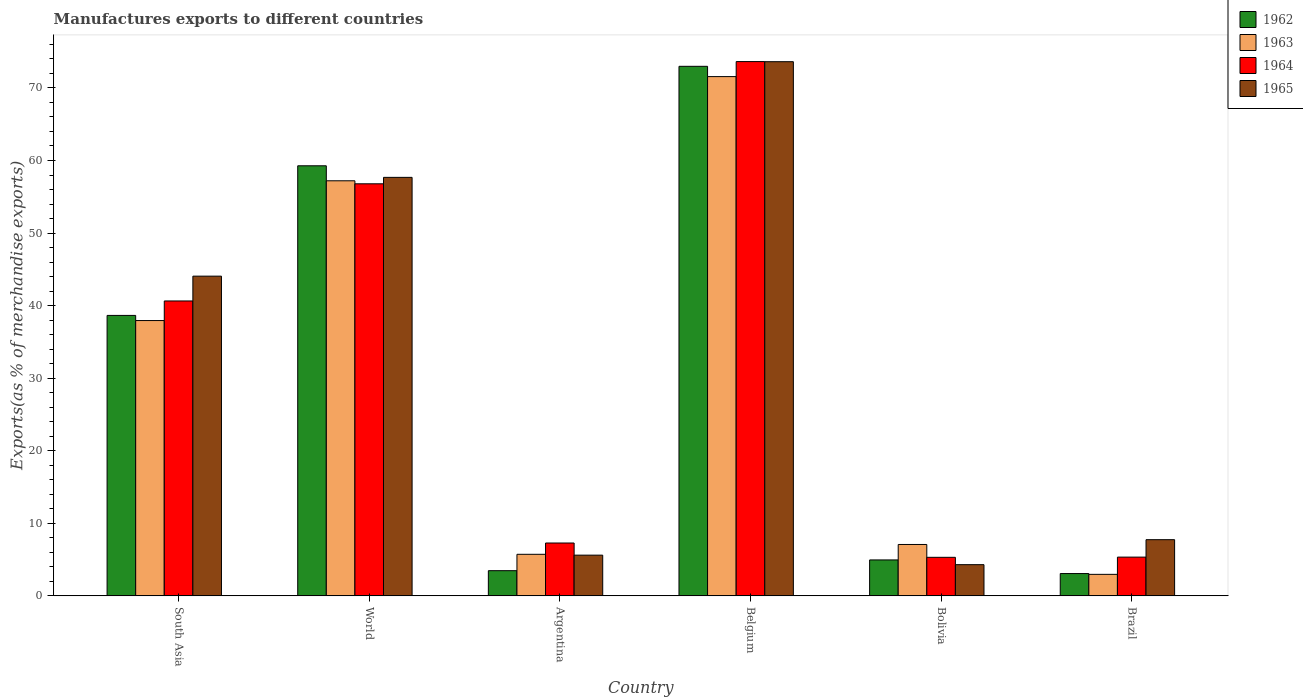How many different coloured bars are there?
Provide a succinct answer. 4. In how many cases, is the number of bars for a given country not equal to the number of legend labels?
Provide a succinct answer. 0. What is the percentage of exports to different countries in 1963 in Belgium?
Your answer should be compact. 71.56. Across all countries, what is the maximum percentage of exports to different countries in 1964?
Provide a short and direct response. 73.63. Across all countries, what is the minimum percentage of exports to different countries in 1963?
Ensure brevity in your answer.  2.96. In which country was the percentage of exports to different countries in 1962 minimum?
Give a very brief answer. Brazil. What is the total percentage of exports to different countries in 1962 in the graph?
Offer a very short reply. 182.39. What is the difference between the percentage of exports to different countries in 1965 in Argentina and that in South Asia?
Your answer should be compact. -38.45. What is the difference between the percentage of exports to different countries in 1965 in South Asia and the percentage of exports to different countries in 1962 in Argentina?
Provide a short and direct response. 40.59. What is the average percentage of exports to different countries in 1963 per country?
Ensure brevity in your answer.  30.41. What is the difference between the percentage of exports to different countries of/in 1963 and percentage of exports to different countries of/in 1962 in Brazil?
Your answer should be very brief. -0.11. In how many countries, is the percentage of exports to different countries in 1965 greater than 48 %?
Your answer should be very brief. 2. What is the ratio of the percentage of exports to different countries in 1964 in Argentina to that in Bolivia?
Offer a very short reply. 1.37. Is the difference between the percentage of exports to different countries in 1963 in South Asia and World greater than the difference between the percentage of exports to different countries in 1962 in South Asia and World?
Offer a terse response. Yes. What is the difference between the highest and the second highest percentage of exports to different countries in 1965?
Your answer should be very brief. 29.56. What is the difference between the highest and the lowest percentage of exports to different countries in 1964?
Make the answer very short. 68.32. In how many countries, is the percentage of exports to different countries in 1963 greater than the average percentage of exports to different countries in 1963 taken over all countries?
Provide a succinct answer. 3. What does the 3rd bar from the left in World represents?
Ensure brevity in your answer.  1964. What does the 2nd bar from the right in Argentina represents?
Give a very brief answer. 1964. Is it the case that in every country, the sum of the percentage of exports to different countries in 1962 and percentage of exports to different countries in 1964 is greater than the percentage of exports to different countries in 1965?
Your answer should be compact. Yes. How many bars are there?
Offer a very short reply. 24. What is the difference between two consecutive major ticks on the Y-axis?
Offer a terse response. 10. Does the graph contain any zero values?
Your response must be concise. No. Does the graph contain grids?
Keep it short and to the point. No. Where does the legend appear in the graph?
Offer a terse response. Top right. How are the legend labels stacked?
Offer a very short reply. Vertical. What is the title of the graph?
Make the answer very short. Manufactures exports to different countries. What is the label or title of the Y-axis?
Keep it short and to the point. Exports(as % of merchandise exports). What is the Exports(as % of merchandise exports) of 1962 in South Asia?
Your answer should be compact. 38.65. What is the Exports(as % of merchandise exports) in 1963 in South Asia?
Make the answer very short. 37.94. What is the Exports(as % of merchandise exports) of 1964 in South Asia?
Offer a terse response. 40.64. What is the Exports(as % of merchandise exports) in 1965 in South Asia?
Your answer should be very brief. 44.06. What is the Exports(as % of merchandise exports) of 1962 in World?
Your answer should be very brief. 59.27. What is the Exports(as % of merchandise exports) in 1963 in World?
Offer a terse response. 57.2. What is the Exports(as % of merchandise exports) of 1964 in World?
Your response must be concise. 56.79. What is the Exports(as % of merchandise exports) in 1965 in World?
Offer a very short reply. 57.68. What is the Exports(as % of merchandise exports) of 1962 in Argentina?
Provide a short and direct response. 3.47. What is the Exports(as % of merchandise exports) of 1963 in Argentina?
Keep it short and to the point. 5.73. What is the Exports(as % of merchandise exports) in 1964 in Argentina?
Your answer should be compact. 7.28. What is the Exports(as % of merchandise exports) of 1965 in Argentina?
Make the answer very short. 5.61. What is the Exports(as % of merchandise exports) in 1962 in Belgium?
Give a very brief answer. 72.98. What is the Exports(as % of merchandise exports) in 1963 in Belgium?
Ensure brevity in your answer.  71.56. What is the Exports(as % of merchandise exports) in 1964 in Belgium?
Ensure brevity in your answer.  73.63. What is the Exports(as % of merchandise exports) in 1965 in Belgium?
Provide a short and direct response. 73.62. What is the Exports(as % of merchandise exports) in 1962 in Bolivia?
Give a very brief answer. 4.95. What is the Exports(as % of merchandise exports) in 1963 in Bolivia?
Ensure brevity in your answer.  7.08. What is the Exports(as % of merchandise exports) of 1964 in Bolivia?
Your response must be concise. 5.31. What is the Exports(as % of merchandise exports) of 1965 in Bolivia?
Your answer should be compact. 4.3. What is the Exports(as % of merchandise exports) in 1962 in Brazil?
Your response must be concise. 3.07. What is the Exports(as % of merchandise exports) of 1963 in Brazil?
Make the answer very short. 2.96. What is the Exports(as % of merchandise exports) in 1964 in Brazil?
Provide a short and direct response. 5.34. What is the Exports(as % of merchandise exports) of 1965 in Brazil?
Offer a very short reply. 7.74. Across all countries, what is the maximum Exports(as % of merchandise exports) in 1962?
Offer a very short reply. 72.98. Across all countries, what is the maximum Exports(as % of merchandise exports) in 1963?
Offer a very short reply. 71.56. Across all countries, what is the maximum Exports(as % of merchandise exports) of 1964?
Offer a terse response. 73.63. Across all countries, what is the maximum Exports(as % of merchandise exports) of 1965?
Provide a short and direct response. 73.62. Across all countries, what is the minimum Exports(as % of merchandise exports) in 1962?
Offer a terse response. 3.07. Across all countries, what is the minimum Exports(as % of merchandise exports) of 1963?
Your answer should be compact. 2.96. Across all countries, what is the minimum Exports(as % of merchandise exports) in 1964?
Offer a very short reply. 5.31. Across all countries, what is the minimum Exports(as % of merchandise exports) of 1965?
Provide a short and direct response. 4.3. What is the total Exports(as % of merchandise exports) in 1962 in the graph?
Your answer should be very brief. 182.39. What is the total Exports(as % of merchandise exports) in 1963 in the graph?
Your response must be concise. 182.48. What is the total Exports(as % of merchandise exports) of 1964 in the graph?
Give a very brief answer. 188.99. What is the total Exports(as % of merchandise exports) of 1965 in the graph?
Give a very brief answer. 193. What is the difference between the Exports(as % of merchandise exports) of 1962 in South Asia and that in World?
Your answer should be very brief. -20.62. What is the difference between the Exports(as % of merchandise exports) of 1963 in South Asia and that in World?
Offer a very short reply. -19.26. What is the difference between the Exports(as % of merchandise exports) in 1964 in South Asia and that in World?
Make the answer very short. -16.15. What is the difference between the Exports(as % of merchandise exports) of 1965 in South Asia and that in World?
Keep it short and to the point. -13.62. What is the difference between the Exports(as % of merchandise exports) in 1962 in South Asia and that in Argentina?
Provide a succinct answer. 35.18. What is the difference between the Exports(as % of merchandise exports) of 1963 in South Asia and that in Argentina?
Offer a terse response. 32.21. What is the difference between the Exports(as % of merchandise exports) of 1964 in South Asia and that in Argentina?
Your response must be concise. 33.36. What is the difference between the Exports(as % of merchandise exports) of 1965 in South Asia and that in Argentina?
Your response must be concise. 38.45. What is the difference between the Exports(as % of merchandise exports) of 1962 in South Asia and that in Belgium?
Your answer should be compact. -34.33. What is the difference between the Exports(as % of merchandise exports) of 1963 in South Asia and that in Belgium?
Offer a terse response. -33.62. What is the difference between the Exports(as % of merchandise exports) in 1964 in South Asia and that in Belgium?
Keep it short and to the point. -32.99. What is the difference between the Exports(as % of merchandise exports) of 1965 in South Asia and that in Belgium?
Provide a succinct answer. -29.56. What is the difference between the Exports(as % of merchandise exports) in 1962 in South Asia and that in Bolivia?
Offer a very short reply. 33.7. What is the difference between the Exports(as % of merchandise exports) of 1963 in South Asia and that in Bolivia?
Provide a short and direct response. 30.86. What is the difference between the Exports(as % of merchandise exports) of 1964 in South Asia and that in Bolivia?
Provide a succinct answer. 35.33. What is the difference between the Exports(as % of merchandise exports) in 1965 in South Asia and that in Bolivia?
Provide a succinct answer. 39.76. What is the difference between the Exports(as % of merchandise exports) in 1962 in South Asia and that in Brazil?
Your response must be concise. 35.58. What is the difference between the Exports(as % of merchandise exports) of 1963 in South Asia and that in Brazil?
Provide a short and direct response. 34.98. What is the difference between the Exports(as % of merchandise exports) of 1964 in South Asia and that in Brazil?
Give a very brief answer. 35.3. What is the difference between the Exports(as % of merchandise exports) in 1965 in South Asia and that in Brazil?
Provide a succinct answer. 36.32. What is the difference between the Exports(as % of merchandise exports) in 1962 in World and that in Argentina?
Provide a succinct answer. 55.8. What is the difference between the Exports(as % of merchandise exports) in 1963 in World and that in Argentina?
Offer a terse response. 51.48. What is the difference between the Exports(as % of merchandise exports) in 1964 in World and that in Argentina?
Give a very brief answer. 49.51. What is the difference between the Exports(as % of merchandise exports) of 1965 in World and that in Argentina?
Your response must be concise. 52.07. What is the difference between the Exports(as % of merchandise exports) of 1962 in World and that in Belgium?
Ensure brevity in your answer.  -13.71. What is the difference between the Exports(as % of merchandise exports) in 1963 in World and that in Belgium?
Offer a terse response. -14.36. What is the difference between the Exports(as % of merchandise exports) in 1964 in World and that in Belgium?
Ensure brevity in your answer.  -16.84. What is the difference between the Exports(as % of merchandise exports) of 1965 in World and that in Belgium?
Your response must be concise. -15.94. What is the difference between the Exports(as % of merchandise exports) in 1962 in World and that in Bolivia?
Your answer should be compact. 54.32. What is the difference between the Exports(as % of merchandise exports) of 1963 in World and that in Bolivia?
Make the answer very short. 50.12. What is the difference between the Exports(as % of merchandise exports) in 1964 in World and that in Bolivia?
Ensure brevity in your answer.  51.48. What is the difference between the Exports(as % of merchandise exports) in 1965 in World and that in Bolivia?
Offer a very short reply. 53.38. What is the difference between the Exports(as % of merchandise exports) in 1962 in World and that in Brazil?
Give a very brief answer. 56.2. What is the difference between the Exports(as % of merchandise exports) in 1963 in World and that in Brazil?
Your answer should be very brief. 54.24. What is the difference between the Exports(as % of merchandise exports) in 1964 in World and that in Brazil?
Offer a terse response. 51.45. What is the difference between the Exports(as % of merchandise exports) of 1965 in World and that in Brazil?
Your response must be concise. 49.94. What is the difference between the Exports(as % of merchandise exports) in 1962 in Argentina and that in Belgium?
Your answer should be compact. -69.51. What is the difference between the Exports(as % of merchandise exports) in 1963 in Argentina and that in Belgium?
Offer a terse response. -65.84. What is the difference between the Exports(as % of merchandise exports) of 1964 in Argentina and that in Belgium?
Give a very brief answer. -66.35. What is the difference between the Exports(as % of merchandise exports) of 1965 in Argentina and that in Belgium?
Offer a very short reply. -68.01. What is the difference between the Exports(as % of merchandise exports) of 1962 in Argentina and that in Bolivia?
Offer a very short reply. -1.48. What is the difference between the Exports(as % of merchandise exports) of 1963 in Argentina and that in Bolivia?
Keep it short and to the point. -1.35. What is the difference between the Exports(as % of merchandise exports) in 1964 in Argentina and that in Bolivia?
Your answer should be very brief. 1.97. What is the difference between the Exports(as % of merchandise exports) of 1965 in Argentina and that in Bolivia?
Offer a very short reply. 1.31. What is the difference between the Exports(as % of merchandise exports) of 1962 in Argentina and that in Brazil?
Your answer should be very brief. 0.4. What is the difference between the Exports(as % of merchandise exports) in 1963 in Argentina and that in Brazil?
Provide a short and direct response. 2.76. What is the difference between the Exports(as % of merchandise exports) of 1964 in Argentina and that in Brazil?
Offer a very short reply. 1.95. What is the difference between the Exports(as % of merchandise exports) in 1965 in Argentina and that in Brazil?
Keep it short and to the point. -2.13. What is the difference between the Exports(as % of merchandise exports) of 1962 in Belgium and that in Bolivia?
Offer a terse response. 68.03. What is the difference between the Exports(as % of merchandise exports) of 1963 in Belgium and that in Bolivia?
Make the answer very short. 64.48. What is the difference between the Exports(as % of merchandise exports) of 1964 in Belgium and that in Bolivia?
Provide a short and direct response. 68.32. What is the difference between the Exports(as % of merchandise exports) in 1965 in Belgium and that in Bolivia?
Your answer should be compact. 69.32. What is the difference between the Exports(as % of merchandise exports) of 1962 in Belgium and that in Brazil?
Provide a succinct answer. 69.91. What is the difference between the Exports(as % of merchandise exports) of 1963 in Belgium and that in Brazil?
Make the answer very short. 68.6. What is the difference between the Exports(as % of merchandise exports) in 1964 in Belgium and that in Brazil?
Offer a terse response. 68.3. What is the difference between the Exports(as % of merchandise exports) in 1965 in Belgium and that in Brazil?
Make the answer very short. 65.88. What is the difference between the Exports(as % of merchandise exports) of 1962 in Bolivia and that in Brazil?
Your answer should be compact. 1.88. What is the difference between the Exports(as % of merchandise exports) of 1963 in Bolivia and that in Brazil?
Provide a short and direct response. 4.12. What is the difference between the Exports(as % of merchandise exports) in 1964 in Bolivia and that in Brazil?
Provide a short and direct response. -0.03. What is the difference between the Exports(as % of merchandise exports) of 1965 in Bolivia and that in Brazil?
Give a very brief answer. -3.44. What is the difference between the Exports(as % of merchandise exports) in 1962 in South Asia and the Exports(as % of merchandise exports) in 1963 in World?
Your response must be concise. -18.56. What is the difference between the Exports(as % of merchandise exports) in 1962 in South Asia and the Exports(as % of merchandise exports) in 1964 in World?
Make the answer very short. -18.14. What is the difference between the Exports(as % of merchandise exports) in 1962 in South Asia and the Exports(as % of merchandise exports) in 1965 in World?
Provide a short and direct response. -19.03. What is the difference between the Exports(as % of merchandise exports) of 1963 in South Asia and the Exports(as % of merchandise exports) of 1964 in World?
Your answer should be very brief. -18.85. What is the difference between the Exports(as % of merchandise exports) in 1963 in South Asia and the Exports(as % of merchandise exports) in 1965 in World?
Make the answer very short. -19.74. What is the difference between the Exports(as % of merchandise exports) of 1964 in South Asia and the Exports(as % of merchandise exports) of 1965 in World?
Provide a succinct answer. -17.04. What is the difference between the Exports(as % of merchandise exports) of 1962 in South Asia and the Exports(as % of merchandise exports) of 1963 in Argentina?
Offer a very short reply. 32.92. What is the difference between the Exports(as % of merchandise exports) of 1962 in South Asia and the Exports(as % of merchandise exports) of 1964 in Argentina?
Provide a short and direct response. 31.37. What is the difference between the Exports(as % of merchandise exports) in 1962 in South Asia and the Exports(as % of merchandise exports) in 1965 in Argentina?
Offer a very short reply. 33.04. What is the difference between the Exports(as % of merchandise exports) in 1963 in South Asia and the Exports(as % of merchandise exports) in 1964 in Argentina?
Provide a short and direct response. 30.66. What is the difference between the Exports(as % of merchandise exports) of 1963 in South Asia and the Exports(as % of merchandise exports) of 1965 in Argentina?
Provide a succinct answer. 32.33. What is the difference between the Exports(as % of merchandise exports) of 1964 in South Asia and the Exports(as % of merchandise exports) of 1965 in Argentina?
Your answer should be very brief. 35.03. What is the difference between the Exports(as % of merchandise exports) in 1962 in South Asia and the Exports(as % of merchandise exports) in 1963 in Belgium?
Ensure brevity in your answer.  -32.92. What is the difference between the Exports(as % of merchandise exports) in 1962 in South Asia and the Exports(as % of merchandise exports) in 1964 in Belgium?
Make the answer very short. -34.98. What is the difference between the Exports(as % of merchandise exports) in 1962 in South Asia and the Exports(as % of merchandise exports) in 1965 in Belgium?
Ensure brevity in your answer.  -34.97. What is the difference between the Exports(as % of merchandise exports) in 1963 in South Asia and the Exports(as % of merchandise exports) in 1964 in Belgium?
Give a very brief answer. -35.69. What is the difference between the Exports(as % of merchandise exports) of 1963 in South Asia and the Exports(as % of merchandise exports) of 1965 in Belgium?
Keep it short and to the point. -35.68. What is the difference between the Exports(as % of merchandise exports) in 1964 in South Asia and the Exports(as % of merchandise exports) in 1965 in Belgium?
Provide a succinct answer. -32.98. What is the difference between the Exports(as % of merchandise exports) of 1962 in South Asia and the Exports(as % of merchandise exports) of 1963 in Bolivia?
Keep it short and to the point. 31.57. What is the difference between the Exports(as % of merchandise exports) in 1962 in South Asia and the Exports(as % of merchandise exports) in 1964 in Bolivia?
Offer a very short reply. 33.34. What is the difference between the Exports(as % of merchandise exports) in 1962 in South Asia and the Exports(as % of merchandise exports) in 1965 in Bolivia?
Ensure brevity in your answer.  34.35. What is the difference between the Exports(as % of merchandise exports) in 1963 in South Asia and the Exports(as % of merchandise exports) in 1964 in Bolivia?
Give a very brief answer. 32.63. What is the difference between the Exports(as % of merchandise exports) in 1963 in South Asia and the Exports(as % of merchandise exports) in 1965 in Bolivia?
Offer a very short reply. 33.64. What is the difference between the Exports(as % of merchandise exports) in 1964 in South Asia and the Exports(as % of merchandise exports) in 1965 in Bolivia?
Your response must be concise. 36.34. What is the difference between the Exports(as % of merchandise exports) in 1962 in South Asia and the Exports(as % of merchandise exports) in 1963 in Brazil?
Your answer should be compact. 35.69. What is the difference between the Exports(as % of merchandise exports) in 1962 in South Asia and the Exports(as % of merchandise exports) in 1964 in Brazil?
Make the answer very short. 33.31. What is the difference between the Exports(as % of merchandise exports) of 1962 in South Asia and the Exports(as % of merchandise exports) of 1965 in Brazil?
Offer a very short reply. 30.91. What is the difference between the Exports(as % of merchandise exports) in 1963 in South Asia and the Exports(as % of merchandise exports) in 1964 in Brazil?
Make the answer very short. 32.6. What is the difference between the Exports(as % of merchandise exports) of 1963 in South Asia and the Exports(as % of merchandise exports) of 1965 in Brazil?
Offer a terse response. 30.2. What is the difference between the Exports(as % of merchandise exports) of 1964 in South Asia and the Exports(as % of merchandise exports) of 1965 in Brazil?
Keep it short and to the point. 32.9. What is the difference between the Exports(as % of merchandise exports) in 1962 in World and the Exports(as % of merchandise exports) in 1963 in Argentina?
Provide a short and direct response. 53.55. What is the difference between the Exports(as % of merchandise exports) of 1962 in World and the Exports(as % of merchandise exports) of 1964 in Argentina?
Your answer should be very brief. 51.99. What is the difference between the Exports(as % of merchandise exports) in 1962 in World and the Exports(as % of merchandise exports) in 1965 in Argentina?
Provide a short and direct response. 53.66. What is the difference between the Exports(as % of merchandise exports) of 1963 in World and the Exports(as % of merchandise exports) of 1964 in Argentina?
Provide a short and direct response. 49.92. What is the difference between the Exports(as % of merchandise exports) in 1963 in World and the Exports(as % of merchandise exports) in 1965 in Argentina?
Ensure brevity in your answer.  51.59. What is the difference between the Exports(as % of merchandise exports) of 1964 in World and the Exports(as % of merchandise exports) of 1965 in Argentina?
Provide a short and direct response. 51.18. What is the difference between the Exports(as % of merchandise exports) of 1962 in World and the Exports(as % of merchandise exports) of 1963 in Belgium?
Your answer should be very brief. -12.29. What is the difference between the Exports(as % of merchandise exports) in 1962 in World and the Exports(as % of merchandise exports) in 1964 in Belgium?
Give a very brief answer. -14.36. What is the difference between the Exports(as % of merchandise exports) in 1962 in World and the Exports(as % of merchandise exports) in 1965 in Belgium?
Your answer should be very brief. -14.35. What is the difference between the Exports(as % of merchandise exports) in 1963 in World and the Exports(as % of merchandise exports) in 1964 in Belgium?
Offer a terse response. -16.43. What is the difference between the Exports(as % of merchandise exports) in 1963 in World and the Exports(as % of merchandise exports) in 1965 in Belgium?
Your answer should be compact. -16.41. What is the difference between the Exports(as % of merchandise exports) of 1964 in World and the Exports(as % of merchandise exports) of 1965 in Belgium?
Your answer should be compact. -16.83. What is the difference between the Exports(as % of merchandise exports) in 1962 in World and the Exports(as % of merchandise exports) in 1963 in Bolivia?
Keep it short and to the point. 52.19. What is the difference between the Exports(as % of merchandise exports) of 1962 in World and the Exports(as % of merchandise exports) of 1964 in Bolivia?
Ensure brevity in your answer.  53.96. What is the difference between the Exports(as % of merchandise exports) of 1962 in World and the Exports(as % of merchandise exports) of 1965 in Bolivia?
Offer a very short reply. 54.97. What is the difference between the Exports(as % of merchandise exports) of 1963 in World and the Exports(as % of merchandise exports) of 1964 in Bolivia?
Make the answer very short. 51.89. What is the difference between the Exports(as % of merchandise exports) in 1963 in World and the Exports(as % of merchandise exports) in 1965 in Bolivia?
Give a very brief answer. 52.91. What is the difference between the Exports(as % of merchandise exports) in 1964 in World and the Exports(as % of merchandise exports) in 1965 in Bolivia?
Make the answer very short. 52.49. What is the difference between the Exports(as % of merchandise exports) of 1962 in World and the Exports(as % of merchandise exports) of 1963 in Brazil?
Keep it short and to the point. 56.31. What is the difference between the Exports(as % of merchandise exports) in 1962 in World and the Exports(as % of merchandise exports) in 1964 in Brazil?
Make the answer very short. 53.93. What is the difference between the Exports(as % of merchandise exports) in 1962 in World and the Exports(as % of merchandise exports) in 1965 in Brazil?
Your answer should be compact. 51.53. What is the difference between the Exports(as % of merchandise exports) in 1963 in World and the Exports(as % of merchandise exports) in 1964 in Brazil?
Your answer should be very brief. 51.87. What is the difference between the Exports(as % of merchandise exports) in 1963 in World and the Exports(as % of merchandise exports) in 1965 in Brazil?
Make the answer very short. 49.46. What is the difference between the Exports(as % of merchandise exports) in 1964 in World and the Exports(as % of merchandise exports) in 1965 in Brazil?
Offer a very short reply. 49.05. What is the difference between the Exports(as % of merchandise exports) of 1962 in Argentina and the Exports(as % of merchandise exports) of 1963 in Belgium?
Offer a terse response. -68.1. What is the difference between the Exports(as % of merchandise exports) in 1962 in Argentina and the Exports(as % of merchandise exports) in 1964 in Belgium?
Keep it short and to the point. -70.16. What is the difference between the Exports(as % of merchandise exports) in 1962 in Argentina and the Exports(as % of merchandise exports) in 1965 in Belgium?
Provide a short and direct response. -70.15. What is the difference between the Exports(as % of merchandise exports) of 1963 in Argentina and the Exports(as % of merchandise exports) of 1964 in Belgium?
Provide a short and direct response. -67.91. What is the difference between the Exports(as % of merchandise exports) in 1963 in Argentina and the Exports(as % of merchandise exports) in 1965 in Belgium?
Your answer should be compact. -67.89. What is the difference between the Exports(as % of merchandise exports) in 1964 in Argentina and the Exports(as % of merchandise exports) in 1965 in Belgium?
Keep it short and to the point. -66.33. What is the difference between the Exports(as % of merchandise exports) in 1962 in Argentina and the Exports(as % of merchandise exports) in 1963 in Bolivia?
Your answer should be compact. -3.61. What is the difference between the Exports(as % of merchandise exports) in 1962 in Argentina and the Exports(as % of merchandise exports) in 1964 in Bolivia?
Offer a terse response. -1.84. What is the difference between the Exports(as % of merchandise exports) in 1962 in Argentina and the Exports(as % of merchandise exports) in 1965 in Bolivia?
Ensure brevity in your answer.  -0.83. What is the difference between the Exports(as % of merchandise exports) of 1963 in Argentina and the Exports(as % of merchandise exports) of 1964 in Bolivia?
Your response must be concise. 0.42. What is the difference between the Exports(as % of merchandise exports) of 1963 in Argentina and the Exports(as % of merchandise exports) of 1965 in Bolivia?
Your answer should be compact. 1.43. What is the difference between the Exports(as % of merchandise exports) of 1964 in Argentina and the Exports(as % of merchandise exports) of 1965 in Bolivia?
Offer a very short reply. 2.98. What is the difference between the Exports(as % of merchandise exports) of 1962 in Argentina and the Exports(as % of merchandise exports) of 1963 in Brazil?
Your answer should be compact. 0.51. What is the difference between the Exports(as % of merchandise exports) of 1962 in Argentina and the Exports(as % of merchandise exports) of 1964 in Brazil?
Your response must be concise. -1.87. What is the difference between the Exports(as % of merchandise exports) of 1962 in Argentina and the Exports(as % of merchandise exports) of 1965 in Brazil?
Give a very brief answer. -4.27. What is the difference between the Exports(as % of merchandise exports) in 1963 in Argentina and the Exports(as % of merchandise exports) in 1964 in Brazil?
Give a very brief answer. 0.39. What is the difference between the Exports(as % of merchandise exports) of 1963 in Argentina and the Exports(as % of merchandise exports) of 1965 in Brazil?
Your answer should be compact. -2.01. What is the difference between the Exports(as % of merchandise exports) of 1964 in Argentina and the Exports(as % of merchandise exports) of 1965 in Brazil?
Ensure brevity in your answer.  -0.46. What is the difference between the Exports(as % of merchandise exports) of 1962 in Belgium and the Exports(as % of merchandise exports) of 1963 in Bolivia?
Keep it short and to the point. 65.9. What is the difference between the Exports(as % of merchandise exports) in 1962 in Belgium and the Exports(as % of merchandise exports) in 1964 in Bolivia?
Your answer should be very brief. 67.67. What is the difference between the Exports(as % of merchandise exports) in 1962 in Belgium and the Exports(as % of merchandise exports) in 1965 in Bolivia?
Offer a terse response. 68.68. What is the difference between the Exports(as % of merchandise exports) in 1963 in Belgium and the Exports(as % of merchandise exports) in 1964 in Bolivia?
Give a very brief answer. 66.25. What is the difference between the Exports(as % of merchandise exports) of 1963 in Belgium and the Exports(as % of merchandise exports) of 1965 in Bolivia?
Provide a succinct answer. 67.27. What is the difference between the Exports(as % of merchandise exports) in 1964 in Belgium and the Exports(as % of merchandise exports) in 1965 in Bolivia?
Keep it short and to the point. 69.34. What is the difference between the Exports(as % of merchandise exports) in 1962 in Belgium and the Exports(as % of merchandise exports) in 1963 in Brazil?
Offer a terse response. 70.02. What is the difference between the Exports(as % of merchandise exports) in 1962 in Belgium and the Exports(as % of merchandise exports) in 1964 in Brazil?
Provide a succinct answer. 67.64. What is the difference between the Exports(as % of merchandise exports) of 1962 in Belgium and the Exports(as % of merchandise exports) of 1965 in Brazil?
Give a very brief answer. 65.24. What is the difference between the Exports(as % of merchandise exports) in 1963 in Belgium and the Exports(as % of merchandise exports) in 1964 in Brazil?
Make the answer very short. 66.23. What is the difference between the Exports(as % of merchandise exports) in 1963 in Belgium and the Exports(as % of merchandise exports) in 1965 in Brazil?
Keep it short and to the point. 63.82. What is the difference between the Exports(as % of merchandise exports) of 1964 in Belgium and the Exports(as % of merchandise exports) of 1965 in Brazil?
Your answer should be compact. 65.89. What is the difference between the Exports(as % of merchandise exports) of 1962 in Bolivia and the Exports(as % of merchandise exports) of 1963 in Brazil?
Ensure brevity in your answer.  1.99. What is the difference between the Exports(as % of merchandise exports) of 1962 in Bolivia and the Exports(as % of merchandise exports) of 1964 in Brazil?
Provide a succinct answer. -0.39. What is the difference between the Exports(as % of merchandise exports) of 1962 in Bolivia and the Exports(as % of merchandise exports) of 1965 in Brazil?
Give a very brief answer. -2.79. What is the difference between the Exports(as % of merchandise exports) of 1963 in Bolivia and the Exports(as % of merchandise exports) of 1964 in Brazil?
Give a very brief answer. 1.74. What is the difference between the Exports(as % of merchandise exports) of 1963 in Bolivia and the Exports(as % of merchandise exports) of 1965 in Brazil?
Your answer should be compact. -0.66. What is the difference between the Exports(as % of merchandise exports) in 1964 in Bolivia and the Exports(as % of merchandise exports) in 1965 in Brazil?
Offer a very short reply. -2.43. What is the average Exports(as % of merchandise exports) of 1962 per country?
Provide a succinct answer. 30.4. What is the average Exports(as % of merchandise exports) of 1963 per country?
Your response must be concise. 30.41. What is the average Exports(as % of merchandise exports) of 1964 per country?
Your response must be concise. 31.5. What is the average Exports(as % of merchandise exports) of 1965 per country?
Offer a very short reply. 32.17. What is the difference between the Exports(as % of merchandise exports) in 1962 and Exports(as % of merchandise exports) in 1963 in South Asia?
Provide a short and direct response. 0.71. What is the difference between the Exports(as % of merchandise exports) of 1962 and Exports(as % of merchandise exports) of 1964 in South Asia?
Your answer should be very brief. -1.99. What is the difference between the Exports(as % of merchandise exports) in 1962 and Exports(as % of merchandise exports) in 1965 in South Asia?
Give a very brief answer. -5.41. What is the difference between the Exports(as % of merchandise exports) of 1963 and Exports(as % of merchandise exports) of 1964 in South Asia?
Make the answer very short. -2.7. What is the difference between the Exports(as % of merchandise exports) in 1963 and Exports(as % of merchandise exports) in 1965 in South Asia?
Offer a very short reply. -6.12. What is the difference between the Exports(as % of merchandise exports) of 1964 and Exports(as % of merchandise exports) of 1965 in South Asia?
Give a very brief answer. -3.42. What is the difference between the Exports(as % of merchandise exports) of 1962 and Exports(as % of merchandise exports) of 1963 in World?
Provide a short and direct response. 2.07. What is the difference between the Exports(as % of merchandise exports) in 1962 and Exports(as % of merchandise exports) in 1964 in World?
Keep it short and to the point. 2.48. What is the difference between the Exports(as % of merchandise exports) of 1962 and Exports(as % of merchandise exports) of 1965 in World?
Provide a succinct answer. 1.59. What is the difference between the Exports(as % of merchandise exports) of 1963 and Exports(as % of merchandise exports) of 1964 in World?
Provide a succinct answer. 0.41. What is the difference between the Exports(as % of merchandise exports) in 1963 and Exports(as % of merchandise exports) in 1965 in World?
Offer a very short reply. -0.47. What is the difference between the Exports(as % of merchandise exports) in 1964 and Exports(as % of merchandise exports) in 1965 in World?
Your response must be concise. -0.89. What is the difference between the Exports(as % of merchandise exports) of 1962 and Exports(as % of merchandise exports) of 1963 in Argentina?
Keep it short and to the point. -2.26. What is the difference between the Exports(as % of merchandise exports) in 1962 and Exports(as % of merchandise exports) in 1964 in Argentina?
Offer a very short reply. -3.81. What is the difference between the Exports(as % of merchandise exports) of 1962 and Exports(as % of merchandise exports) of 1965 in Argentina?
Make the answer very short. -2.14. What is the difference between the Exports(as % of merchandise exports) in 1963 and Exports(as % of merchandise exports) in 1964 in Argentina?
Your answer should be very brief. -1.56. What is the difference between the Exports(as % of merchandise exports) of 1963 and Exports(as % of merchandise exports) of 1965 in Argentina?
Provide a succinct answer. 0.12. What is the difference between the Exports(as % of merchandise exports) in 1964 and Exports(as % of merchandise exports) in 1965 in Argentina?
Offer a very short reply. 1.67. What is the difference between the Exports(as % of merchandise exports) of 1962 and Exports(as % of merchandise exports) of 1963 in Belgium?
Your answer should be compact. 1.42. What is the difference between the Exports(as % of merchandise exports) in 1962 and Exports(as % of merchandise exports) in 1964 in Belgium?
Offer a very short reply. -0.65. What is the difference between the Exports(as % of merchandise exports) in 1962 and Exports(as % of merchandise exports) in 1965 in Belgium?
Your answer should be compact. -0.64. What is the difference between the Exports(as % of merchandise exports) of 1963 and Exports(as % of merchandise exports) of 1964 in Belgium?
Your answer should be very brief. -2.07. What is the difference between the Exports(as % of merchandise exports) of 1963 and Exports(as % of merchandise exports) of 1965 in Belgium?
Offer a terse response. -2.05. What is the difference between the Exports(as % of merchandise exports) of 1964 and Exports(as % of merchandise exports) of 1965 in Belgium?
Provide a succinct answer. 0.02. What is the difference between the Exports(as % of merchandise exports) in 1962 and Exports(as % of merchandise exports) in 1963 in Bolivia?
Your answer should be compact. -2.13. What is the difference between the Exports(as % of merchandise exports) of 1962 and Exports(as % of merchandise exports) of 1964 in Bolivia?
Offer a very short reply. -0.36. What is the difference between the Exports(as % of merchandise exports) of 1962 and Exports(as % of merchandise exports) of 1965 in Bolivia?
Make the answer very short. 0.65. What is the difference between the Exports(as % of merchandise exports) in 1963 and Exports(as % of merchandise exports) in 1964 in Bolivia?
Offer a very short reply. 1.77. What is the difference between the Exports(as % of merchandise exports) of 1963 and Exports(as % of merchandise exports) of 1965 in Bolivia?
Provide a short and direct response. 2.78. What is the difference between the Exports(as % of merchandise exports) in 1964 and Exports(as % of merchandise exports) in 1965 in Bolivia?
Your response must be concise. 1.01. What is the difference between the Exports(as % of merchandise exports) in 1962 and Exports(as % of merchandise exports) in 1963 in Brazil?
Your answer should be compact. 0.11. What is the difference between the Exports(as % of merchandise exports) of 1962 and Exports(as % of merchandise exports) of 1964 in Brazil?
Give a very brief answer. -2.27. What is the difference between the Exports(as % of merchandise exports) in 1962 and Exports(as % of merchandise exports) in 1965 in Brazil?
Offer a very short reply. -4.67. What is the difference between the Exports(as % of merchandise exports) in 1963 and Exports(as % of merchandise exports) in 1964 in Brazil?
Offer a very short reply. -2.37. What is the difference between the Exports(as % of merchandise exports) in 1963 and Exports(as % of merchandise exports) in 1965 in Brazil?
Ensure brevity in your answer.  -4.78. What is the difference between the Exports(as % of merchandise exports) in 1964 and Exports(as % of merchandise exports) in 1965 in Brazil?
Offer a very short reply. -2.4. What is the ratio of the Exports(as % of merchandise exports) of 1962 in South Asia to that in World?
Ensure brevity in your answer.  0.65. What is the ratio of the Exports(as % of merchandise exports) of 1963 in South Asia to that in World?
Ensure brevity in your answer.  0.66. What is the ratio of the Exports(as % of merchandise exports) in 1964 in South Asia to that in World?
Offer a terse response. 0.72. What is the ratio of the Exports(as % of merchandise exports) of 1965 in South Asia to that in World?
Your response must be concise. 0.76. What is the ratio of the Exports(as % of merchandise exports) in 1962 in South Asia to that in Argentina?
Your answer should be compact. 11.14. What is the ratio of the Exports(as % of merchandise exports) in 1963 in South Asia to that in Argentina?
Give a very brief answer. 6.63. What is the ratio of the Exports(as % of merchandise exports) in 1964 in South Asia to that in Argentina?
Provide a succinct answer. 5.58. What is the ratio of the Exports(as % of merchandise exports) of 1965 in South Asia to that in Argentina?
Ensure brevity in your answer.  7.86. What is the ratio of the Exports(as % of merchandise exports) in 1962 in South Asia to that in Belgium?
Provide a succinct answer. 0.53. What is the ratio of the Exports(as % of merchandise exports) in 1963 in South Asia to that in Belgium?
Your response must be concise. 0.53. What is the ratio of the Exports(as % of merchandise exports) of 1964 in South Asia to that in Belgium?
Your answer should be compact. 0.55. What is the ratio of the Exports(as % of merchandise exports) in 1965 in South Asia to that in Belgium?
Make the answer very short. 0.6. What is the ratio of the Exports(as % of merchandise exports) in 1962 in South Asia to that in Bolivia?
Your answer should be compact. 7.81. What is the ratio of the Exports(as % of merchandise exports) of 1963 in South Asia to that in Bolivia?
Your answer should be compact. 5.36. What is the ratio of the Exports(as % of merchandise exports) in 1964 in South Asia to that in Bolivia?
Offer a terse response. 7.65. What is the ratio of the Exports(as % of merchandise exports) in 1965 in South Asia to that in Bolivia?
Provide a short and direct response. 10.25. What is the ratio of the Exports(as % of merchandise exports) of 1962 in South Asia to that in Brazil?
Your answer should be very brief. 12.59. What is the ratio of the Exports(as % of merchandise exports) of 1963 in South Asia to that in Brazil?
Your answer should be compact. 12.81. What is the ratio of the Exports(as % of merchandise exports) in 1964 in South Asia to that in Brazil?
Provide a short and direct response. 7.61. What is the ratio of the Exports(as % of merchandise exports) in 1965 in South Asia to that in Brazil?
Keep it short and to the point. 5.69. What is the ratio of the Exports(as % of merchandise exports) in 1962 in World to that in Argentina?
Give a very brief answer. 17.09. What is the ratio of the Exports(as % of merchandise exports) of 1963 in World to that in Argentina?
Your answer should be very brief. 9.99. What is the ratio of the Exports(as % of merchandise exports) of 1964 in World to that in Argentina?
Provide a short and direct response. 7.8. What is the ratio of the Exports(as % of merchandise exports) in 1965 in World to that in Argentina?
Provide a short and direct response. 10.28. What is the ratio of the Exports(as % of merchandise exports) in 1962 in World to that in Belgium?
Keep it short and to the point. 0.81. What is the ratio of the Exports(as % of merchandise exports) in 1963 in World to that in Belgium?
Ensure brevity in your answer.  0.8. What is the ratio of the Exports(as % of merchandise exports) in 1964 in World to that in Belgium?
Provide a short and direct response. 0.77. What is the ratio of the Exports(as % of merchandise exports) of 1965 in World to that in Belgium?
Your response must be concise. 0.78. What is the ratio of the Exports(as % of merchandise exports) in 1962 in World to that in Bolivia?
Offer a very short reply. 11.97. What is the ratio of the Exports(as % of merchandise exports) of 1963 in World to that in Bolivia?
Offer a terse response. 8.08. What is the ratio of the Exports(as % of merchandise exports) of 1964 in World to that in Bolivia?
Offer a terse response. 10.7. What is the ratio of the Exports(as % of merchandise exports) in 1965 in World to that in Bolivia?
Offer a very short reply. 13.42. What is the ratio of the Exports(as % of merchandise exports) in 1962 in World to that in Brazil?
Make the answer very short. 19.3. What is the ratio of the Exports(as % of merchandise exports) in 1963 in World to that in Brazil?
Make the answer very short. 19.31. What is the ratio of the Exports(as % of merchandise exports) in 1964 in World to that in Brazil?
Offer a terse response. 10.64. What is the ratio of the Exports(as % of merchandise exports) in 1965 in World to that in Brazil?
Offer a very short reply. 7.45. What is the ratio of the Exports(as % of merchandise exports) in 1962 in Argentina to that in Belgium?
Provide a succinct answer. 0.05. What is the ratio of the Exports(as % of merchandise exports) in 1964 in Argentina to that in Belgium?
Make the answer very short. 0.1. What is the ratio of the Exports(as % of merchandise exports) of 1965 in Argentina to that in Belgium?
Your answer should be very brief. 0.08. What is the ratio of the Exports(as % of merchandise exports) in 1962 in Argentina to that in Bolivia?
Ensure brevity in your answer.  0.7. What is the ratio of the Exports(as % of merchandise exports) in 1963 in Argentina to that in Bolivia?
Keep it short and to the point. 0.81. What is the ratio of the Exports(as % of merchandise exports) of 1964 in Argentina to that in Bolivia?
Offer a terse response. 1.37. What is the ratio of the Exports(as % of merchandise exports) in 1965 in Argentina to that in Bolivia?
Offer a terse response. 1.31. What is the ratio of the Exports(as % of merchandise exports) in 1962 in Argentina to that in Brazil?
Your answer should be very brief. 1.13. What is the ratio of the Exports(as % of merchandise exports) of 1963 in Argentina to that in Brazil?
Ensure brevity in your answer.  1.93. What is the ratio of the Exports(as % of merchandise exports) of 1964 in Argentina to that in Brazil?
Make the answer very short. 1.36. What is the ratio of the Exports(as % of merchandise exports) of 1965 in Argentina to that in Brazil?
Provide a succinct answer. 0.72. What is the ratio of the Exports(as % of merchandise exports) in 1962 in Belgium to that in Bolivia?
Provide a succinct answer. 14.74. What is the ratio of the Exports(as % of merchandise exports) of 1963 in Belgium to that in Bolivia?
Your answer should be very brief. 10.11. What is the ratio of the Exports(as % of merchandise exports) of 1964 in Belgium to that in Bolivia?
Give a very brief answer. 13.87. What is the ratio of the Exports(as % of merchandise exports) in 1965 in Belgium to that in Bolivia?
Provide a short and direct response. 17.13. What is the ratio of the Exports(as % of merchandise exports) of 1962 in Belgium to that in Brazil?
Ensure brevity in your answer.  23.77. What is the ratio of the Exports(as % of merchandise exports) in 1963 in Belgium to that in Brazil?
Your answer should be very brief. 24.16. What is the ratio of the Exports(as % of merchandise exports) of 1964 in Belgium to that in Brazil?
Offer a very short reply. 13.8. What is the ratio of the Exports(as % of merchandise exports) in 1965 in Belgium to that in Brazil?
Your answer should be very brief. 9.51. What is the ratio of the Exports(as % of merchandise exports) in 1962 in Bolivia to that in Brazil?
Your answer should be very brief. 1.61. What is the ratio of the Exports(as % of merchandise exports) of 1963 in Bolivia to that in Brazil?
Give a very brief answer. 2.39. What is the ratio of the Exports(as % of merchandise exports) in 1965 in Bolivia to that in Brazil?
Give a very brief answer. 0.56. What is the difference between the highest and the second highest Exports(as % of merchandise exports) of 1962?
Offer a terse response. 13.71. What is the difference between the highest and the second highest Exports(as % of merchandise exports) of 1963?
Your response must be concise. 14.36. What is the difference between the highest and the second highest Exports(as % of merchandise exports) in 1964?
Keep it short and to the point. 16.84. What is the difference between the highest and the second highest Exports(as % of merchandise exports) of 1965?
Offer a very short reply. 15.94. What is the difference between the highest and the lowest Exports(as % of merchandise exports) in 1962?
Make the answer very short. 69.91. What is the difference between the highest and the lowest Exports(as % of merchandise exports) in 1963?
Your answer should be very brief. 68.6. What is the difference between the highest and the lowest Exports(as % of merchandise exports) in 1964?
Make the answer very short. 68.32. What is the difference between the highest and the lowest Exports(as % of merchandise exports) of 1965?
Offer a terse response. 69.32. 